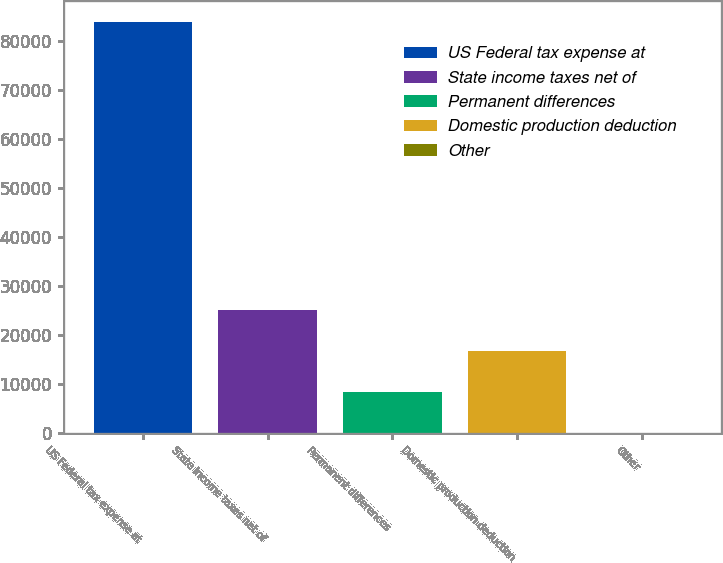Convert chart to OTSL. <chart><loc_0><loc_0><loc_500><loc_500><bar_chart><fcel>US Federal tax expense at<fcel>State income taxes net of<fcel>Permanent differences<fcel>Domestic production deduction<fcel>Other<nl><fcel>83915<fcel>25201.8<fcel>8426.6<fcel>16814.2<fcel>39<nl></chart> 